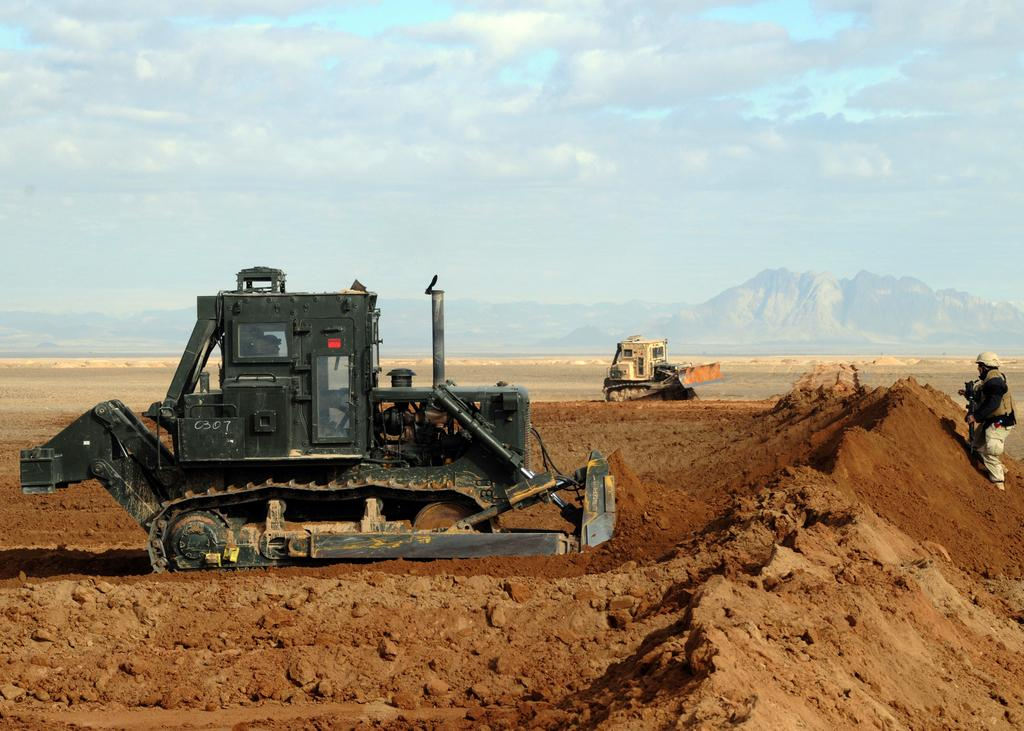How many bulldozers can be seen in the image? There are two bulldozers in the image. What is located on the right side of the bulldozers? There is a person on the right side of the bulldozers. What type of terrain can be seen in the background of the image? There are hills visible in the background of the image. How would you describe the weather based on the sky in the image? The sky is cloudy in the image. What type of body is the beggar holding in the image? There is no beggar present in the image, and therefore no body can be held. 